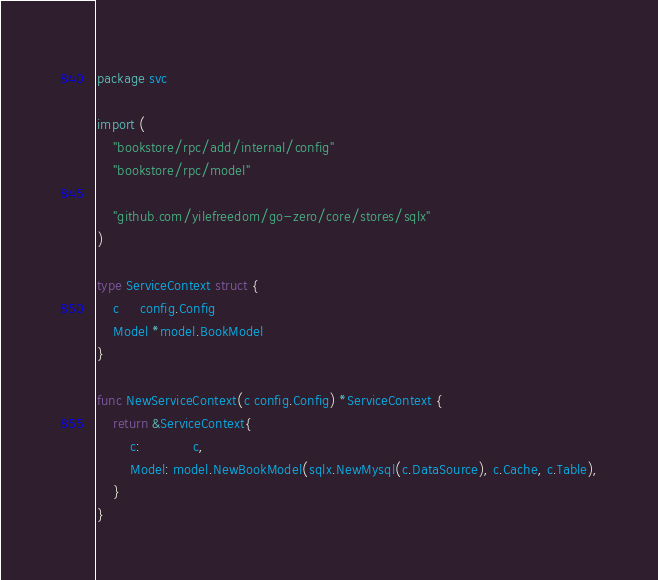Convert code to text. <code><loc_0><loc_0><loc_500><loc_500><_Go_>package svc

import (
	"bookstore/rpc/add/internal/config"
	"bookstore/rpc/model"

	"github.com/yilefreedom/go-zero/core/stores/sqlx"
)

type ServiceContext struct {
	c     config.Config
	Model *model.BookModel
}

func NewServiceContext(c config.Config) *ServiceContext {
	return &ServiceContext{
		c:             c,
		Model: model.NewBookModel(sqlx.NewMysql(c.DataSource), c.Cache, c.Table),
	}
}</code> 